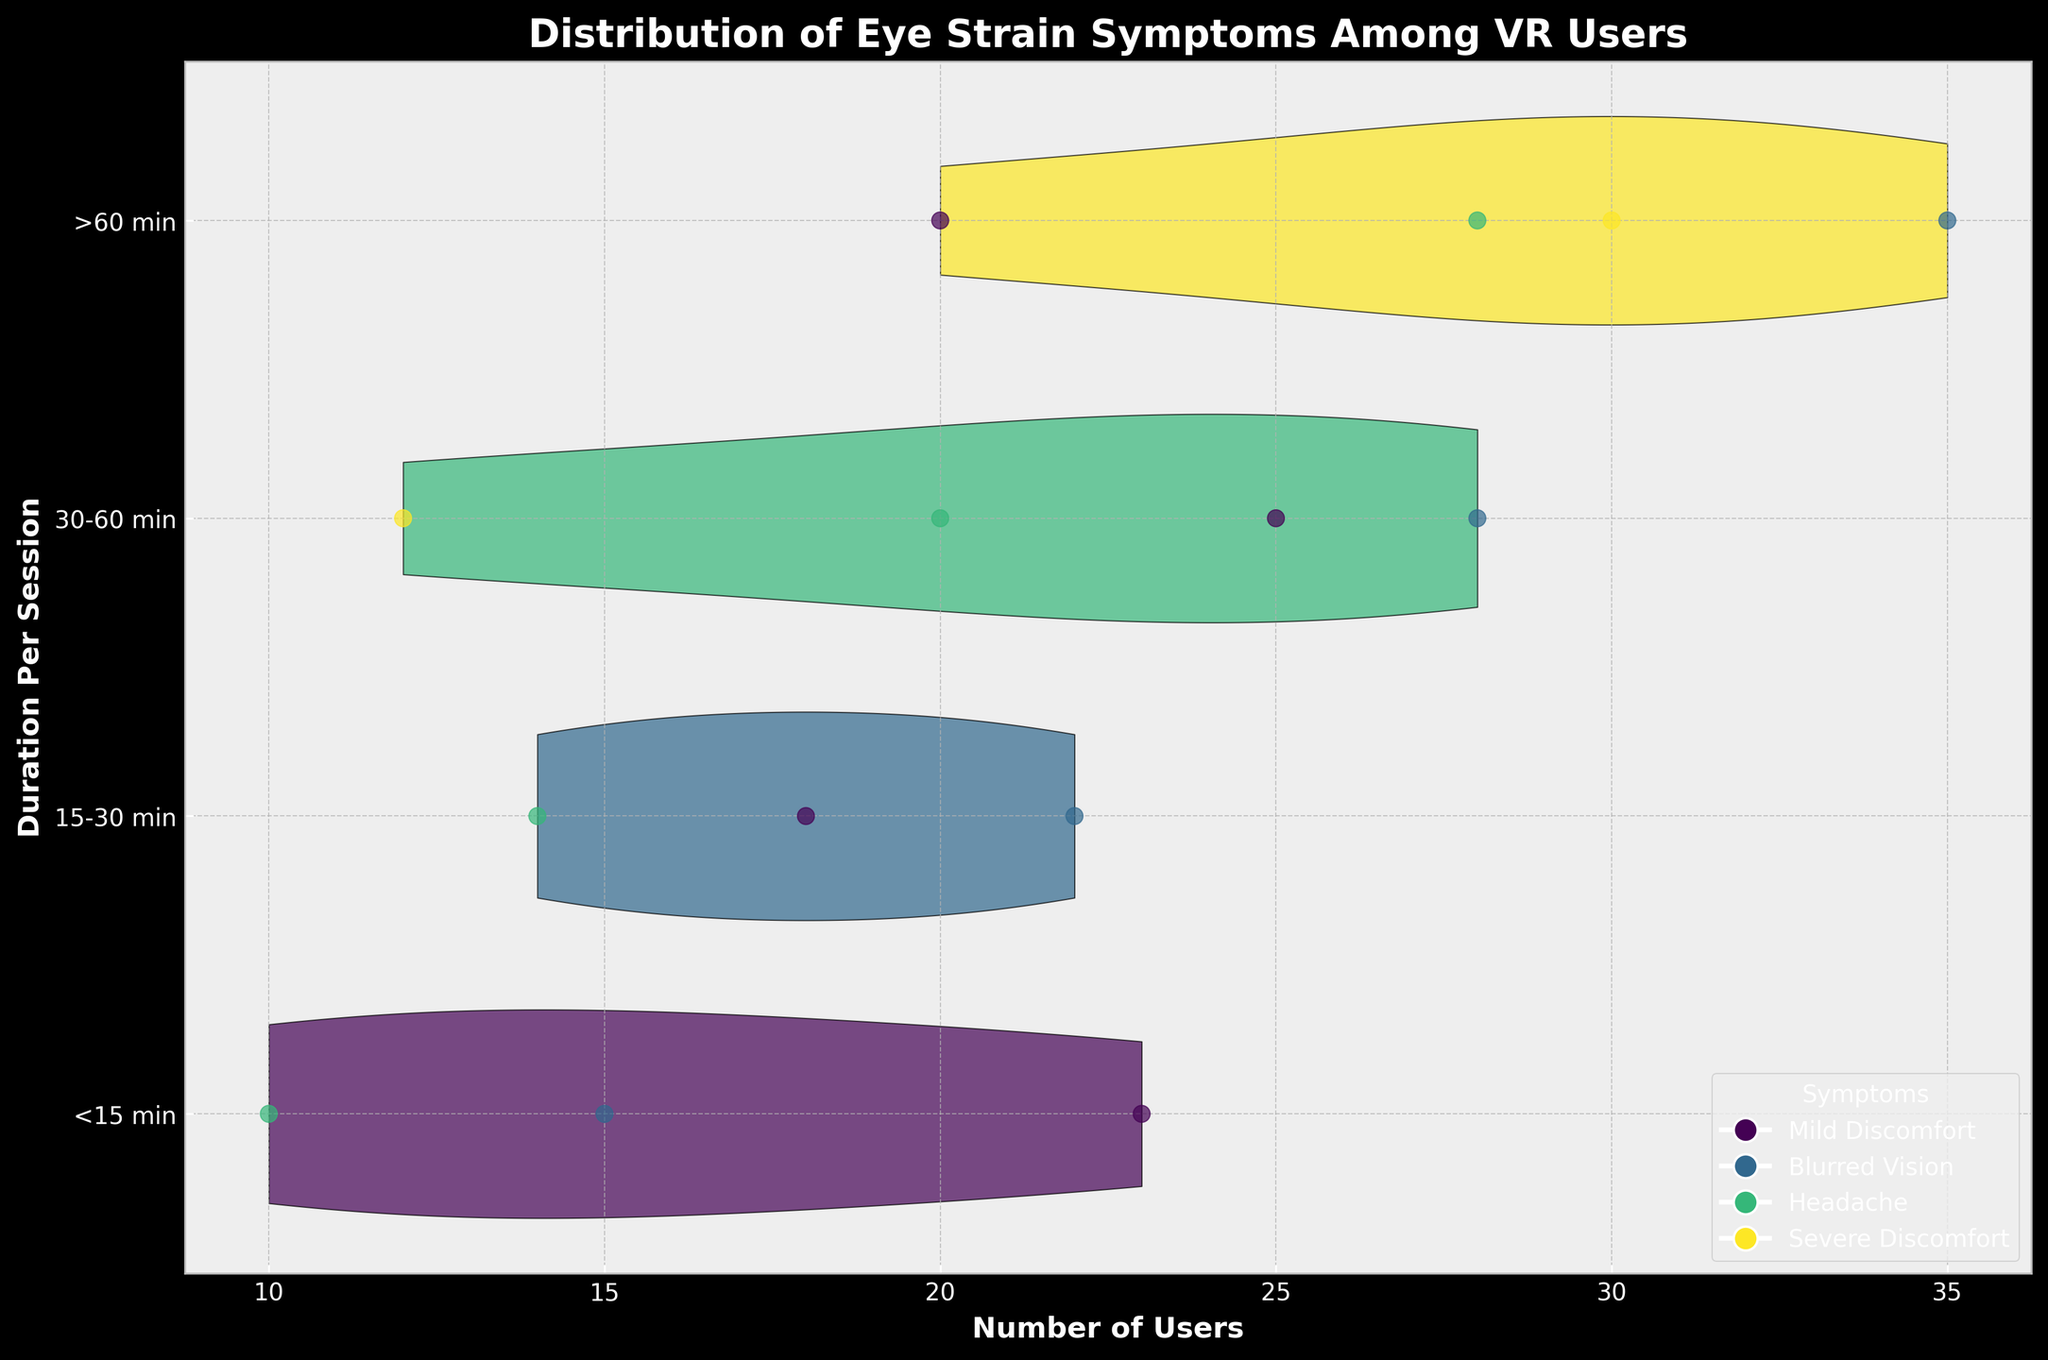What's the title of the chart? The title is usually located at the top of the chart in bold and large font. In this case, it reads "Distribution of Eye Strain Symptoms Among VR Users".
Answer: Distribution of Eye Strain Symptoms Among VR Users How many duration categories are compared in the chart? By looking at the y-axis labels, we can count the number of unique categories. There are 4 categories: "<15 min", "15-30 min", "30-60 min", and ">60 min".
Answer: 4 Which eye strain symptom appears to have the highest number of users for sessions longer than 60 minutes? For the ">60 min" category, we observe different colors representing each symptom. The scatter plot shows that the color representing "Blurred Vision" has the most data points extended horizontally.
Answer: Blurred Vision What symptom is missing in the less than 15-minute session category? By checking which colors are absent in the "<15 min" category, we see that "Severe Discomfort" is not represented.
Answer: Severe Discomfort What is the range of reported numbers for "Headache" in sessions that are 30-60 minutes long? We need to look specifically at the color corresponding to "Headache" within the "30-60 min" category and note the range of the scatter points along the x-axis. This ranges from near 5 to 20.
Answer: 5 to 20 Which duration category shows the widest spread in the number of users experiencing "Mild Discomfort"? Observing the scatter points of the color corresponding to "Mild Discomfort", the "30-60 min" category has the widest spread along the x-axis.
Answer: 30-60 min Compare the number of users experiencing "Blurred Vision" between sessions of 15-30 minutes and those over 60 minutes. Which has more? By observing and comparing the spread and concentration of scatter points for the "Blurred Vision" color between the two durations, the ">60 min" category clearly has more users.
Answer: >60 min What is the total number of symptoms reported for sessions longer than 60 minutes? By looking at the scatter points for each symptom in the ">60 min" category and summing them: 20 (Mild Discomfort) + 35 (Blurred Vision) + 28 (Headache) + 30 (Severe Discomfort) = 113.
Answer: 113 What duration category experiences the most severe discomfort among users? Compare with other categories. By counting the scatter points representing "Severe Discomfort" across all categories, ">60 min" has significantly more instances than any other category.
Answer: >60 min Are there more users experiencing "Severe Discomfort" for sessions longer than 60 minutes or "Headache" for sessions of 30-60 minutes? Counting the scatter points, there are 30 users reporting "Severe Discomfort" in sessions longer than 60 minutes and 20 users reporting "Headache" in sessions of 30-60 minutes.
Answer: Severe Discomfort for >60 min 